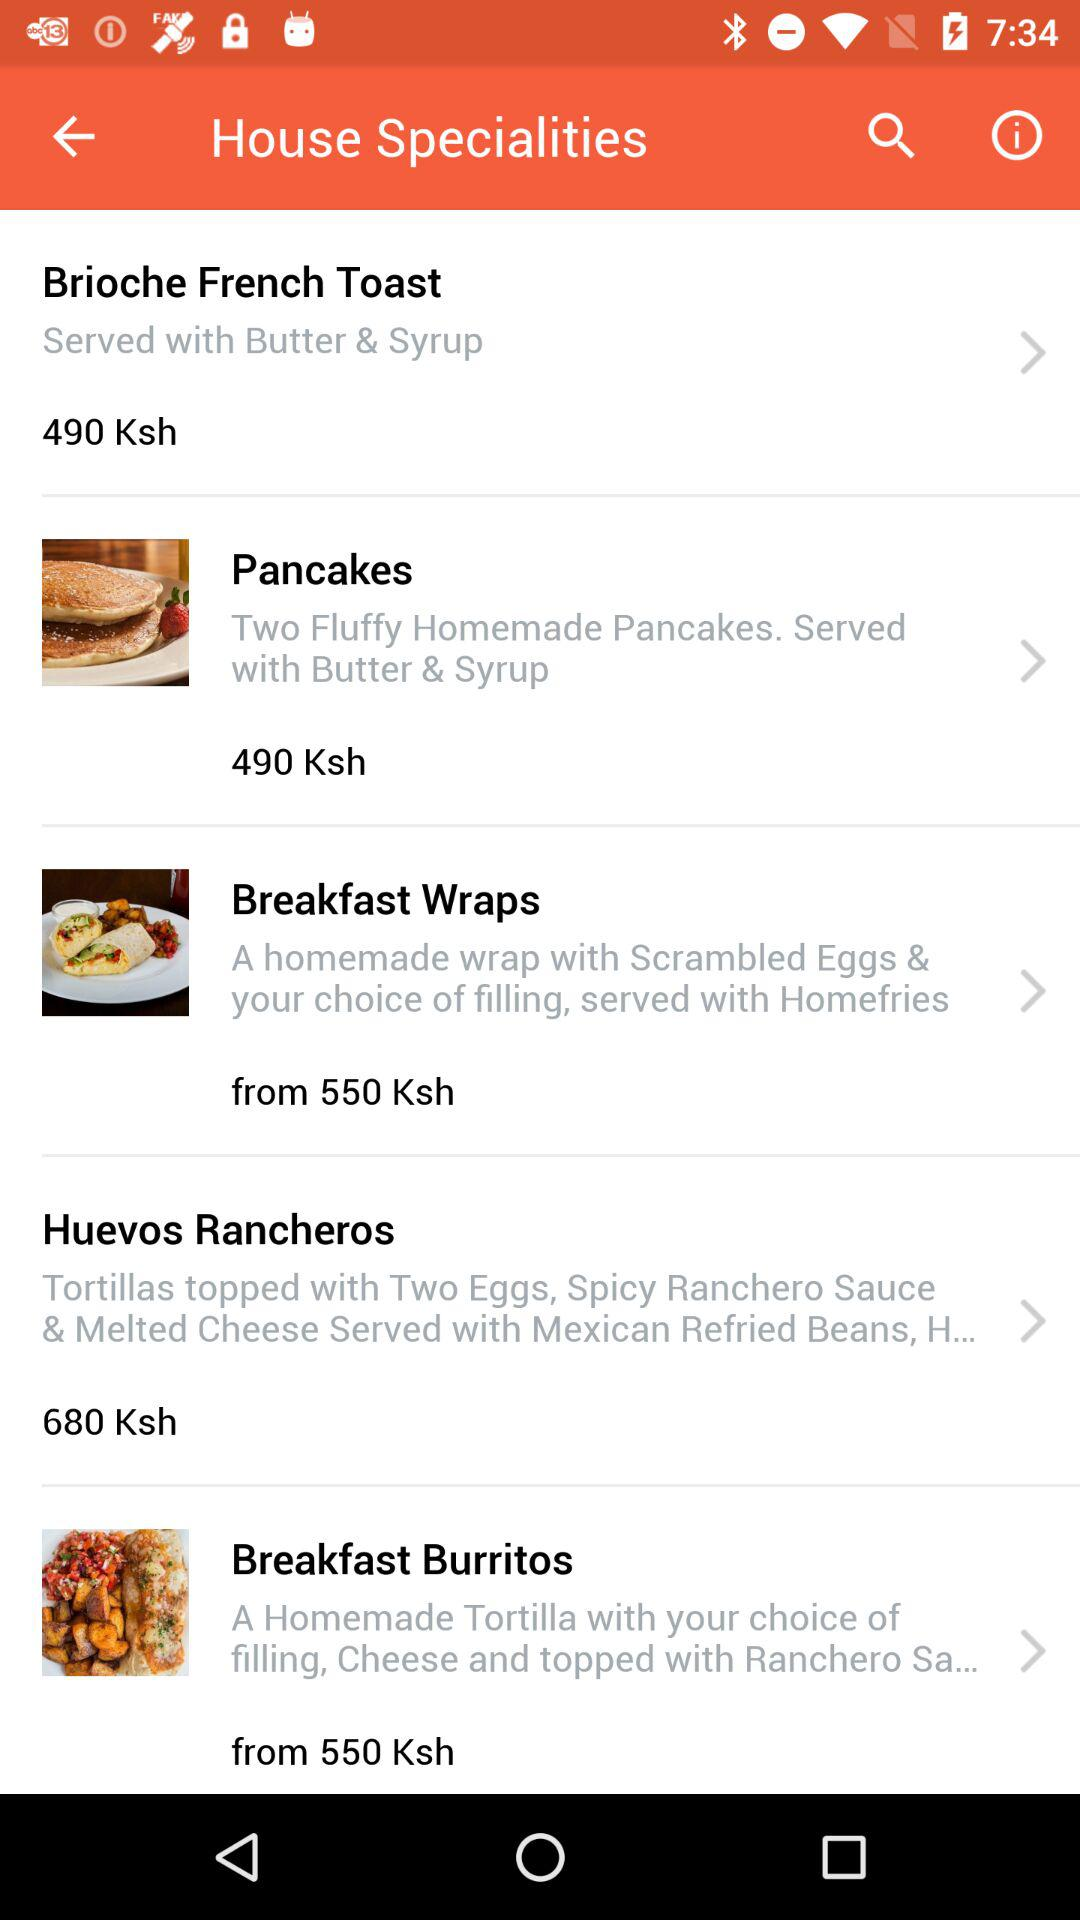What is the price of the "Pancakes"? The price of the "Pancakes" is 490 KSh. 